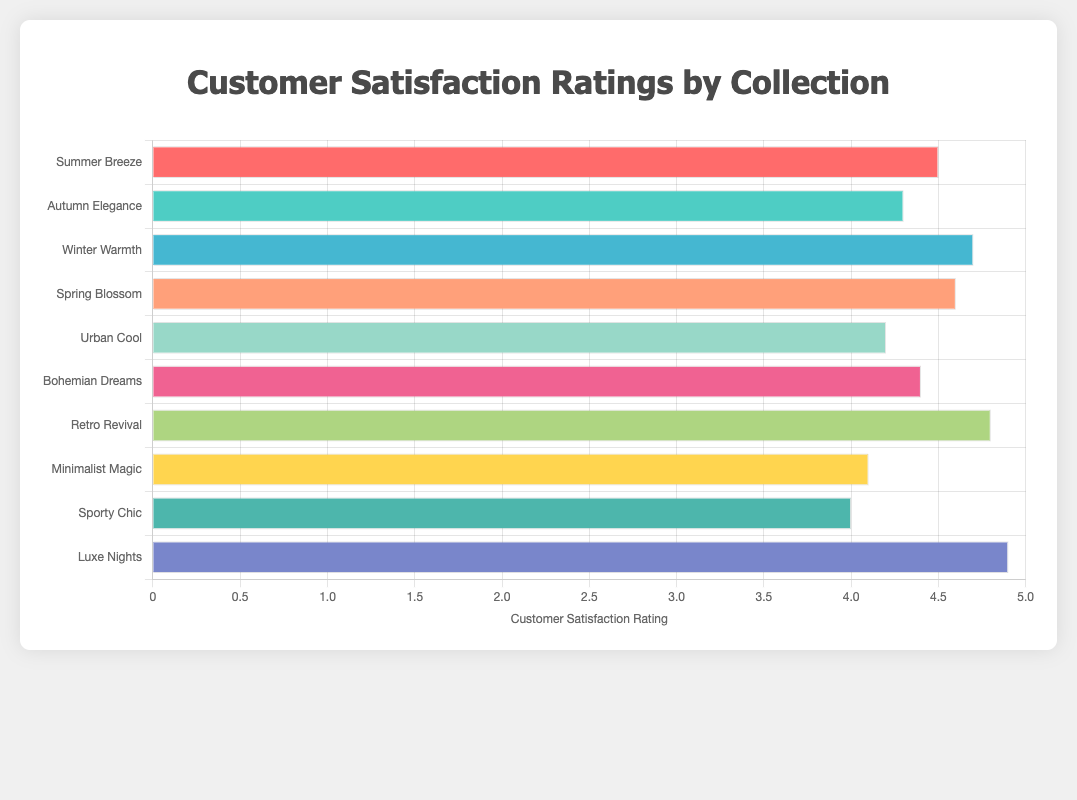Which collection has the highest customer satisfaction rating? By observing the lengths of the bars, we can see that the "Luxe Nights by GlamGoddess" collection has the longest bar, indicating it has the highest satisfaction rating.
Answer: Luxe Nights by GlamGoddess What is the difference in customer satisfaction rating between the highest and lowest-rated collections? The highest-rated collection is "Luxe Nights by GlamGoddess" with a 4.9 rating, and the lowest-rated collection is "Sporty Chic by ActiveWearGuru" with a 4.0 rating. Subtracting these gives 4.9 - 4.0.
Answer: 0.9 Which collection has a higher customer satisfaction rating, "Summer Breeze by StyleGuru" or "Urban Cool by CitySwag"? By comparing the lengths of the respective bars, "Summer Breeze by StyleGuru" has a rating of 4.5 and "Urban Cool by CitySwag" has a rating of 4.2. Since 4.5 is greater than 4.2, "Summer Breeze by StyleGuru" has a higher rating.
Answer: Summer Breeze by StyleGuru How many collections have a customer satisfaction rating greater than or equal to 4.5? By counting the bars that extend to at least the 4.5 point on the x-axis, we find the collections: "Summer Breeze by StyleGuru," "Winter Warmth by CozyFashionista," "Spring Blossom by NatureChic," "Retro Revival by VintageVogue," and "Luxe Nights by GlamGoddess," totaling 5 collections.
Answer: 5 What is the average customer satisfaction rating of all the collections? Sum the ratings of all collections and divide by the number of collections: (4.5 + 4.3 + 4.7 + 4.6 + 4.2 + 4.4 + 4.8 + 4.1 + 4.0 + 4.9) / 10 gives 44.5 / 10.
Answer: 4.45 What is the total customer satisfaction rating for the collections designed by “CitySwag” and “ActiveWearGuru”? The ratings for "Urban Cool by CitySwag" and "Sporty Chic by ActiveWearGuru" are 4.2 and 4.0, respectively. Adding these gives 4.2 + 4.0.
Answer: 8.2 Which collection has the third-highest customer satisfaction rating? Ordering the collections by ratings, we get: 4.9, 4.8, 4.7, 4.6, 4.5, etc. The third-highest rating is held by "Winter Warmth by CozyFashionista" with a score of 4.7.
Answer: Winter Warmth by CozyFashionista What is the median customer satisfaction rating of the collections? Listing the ratings in ascending order: 4.0, 4.1, 4.2, 4.3, 4.4, 4.5, 4.6, 4.7, 4.8, 4.9. The median value (the middle value in an ordered list) is the average of the 5th and 6th values: (4.4 + 4.5) / 2.
Answer: 4.45 